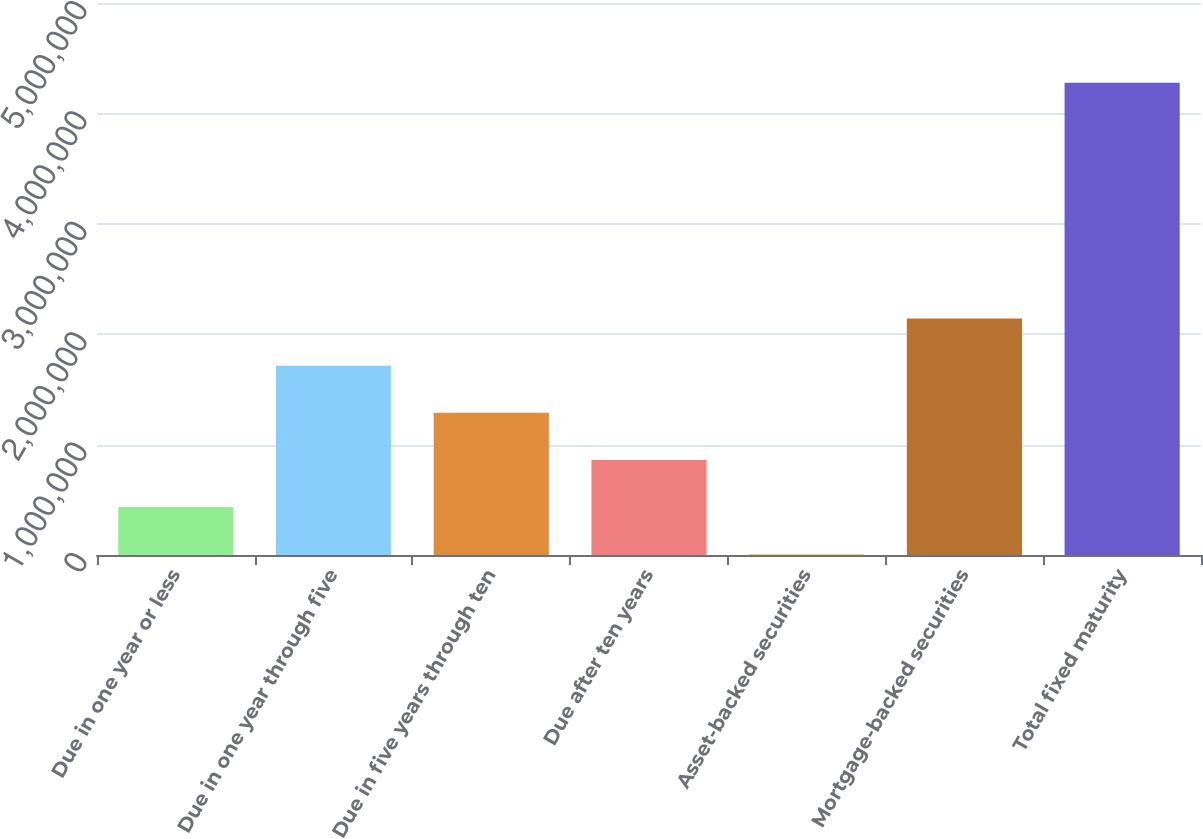<chart> <loc_0><loc_0><loc_500><loc_500><bar_chart><fcel>Due in one year or less<fcel>Due in one year through five<fcel>Due in five years through ten<fcel>Due after ten years<fcel>Asset-backed securities<fcel>Mortgage-backed securities<fcel>Total fixed maturity<nl><fcel>433673<fcel>1.71483e+06<fcel>1.28778e+06<fcel>860725<fcel>6622<fcel>2.14188e+06<fcel>4.27714e+06<nl></chart> 